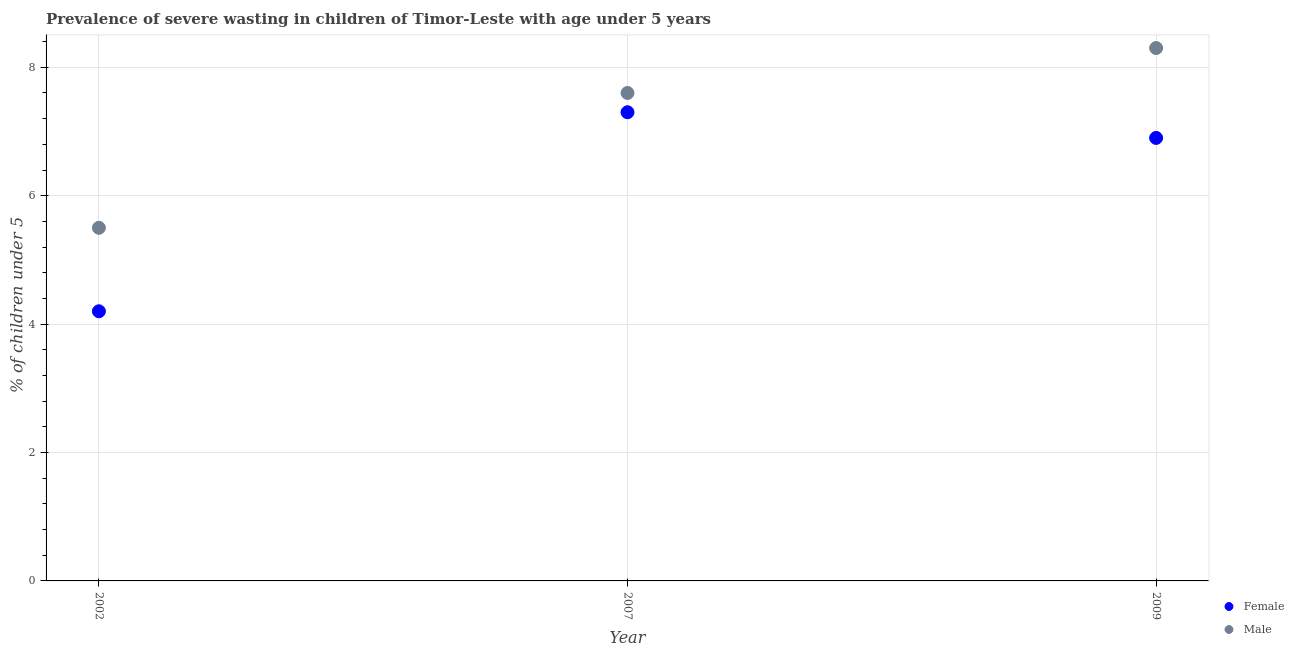How many different coloured dotlines are there?
Ensure brevity in your answer.  2. What is the percentage of undernourished male children in 2007?
Your answer should be very brief. 7.6. Across all years, what is the maximum percentage of undernourished male children?
Offer a terse response. 8.3. In which year was the percentage of undernourished male children maximum?
Offer a very short reply. 2009. In which year was the percentage of undernourished male children minimum?
Your response must be concise. 2002. What is the total percentage of undernourished male children in the graph?
Keep it short and to the point. 21.4. What is the difference between the percentage of undernourished female children in 2007 and that in 2009?
Provide a succinct answer. 0.4. What is the difference between the percentage of undernourished male children in 2002 and the percentage of undernourished female children in 2009?
Make the answer very short. -1.4. What is the average percentage of undernourished male children per year?
Keep it short and to the point. 7.13. In the year 2007, what is the difference between the percentage of undernourished male children and percentage of undernourished female children?
Provide a short and direct response. 0.3. In how many years, is the percentage of undernourished male children greater than 6 %?
Provide a short and direct response. 2. What is the ratio of the percentage of undernourished female children in 2002 to that in 2007?
Keep it short and to the point. 0.58. Is the percentage of undernourished male children in 2002 less than that in 2007?
Give a very brief answer. Yes. Is the difference between the percentage of undernourished male children in 2002 and 2007 greater than the difference between the percentage of undernourished female children in 2002 and 2007?
Provide a succinct answer. Yes. What is the difference between the highest and the second highest percentage of undernourished female children?
Offer a very short reply. 0.4. What is the difference between the highest and the lowest percentage of undernourished male children?
Keep it short and to the point. 2.8. Is the sum of the percentage of undernourished male children in 2002 and 2009 greater than the maximum percentage of undernourished female children across all years?
Offer a terse response. Yes. Does the percentage of undernourished female children monotonically increase over the years?
Your answer should be compact. No. Is the percentage of undernourished female children strictly greater than the percentage of undernourished male children over the years?
Your answer should be compact. No. How many dotlines are there?
Your answer should be very brief. 2. What is the difference between two consecutive major ticks on the Y-axis?
Your answer should be compact. 2. Are the values on the major ticks of Y-axis written in scientific E-notation?
Keep it short and to the point. No. Does the graph contain any zero values?
Provide a succinct answer. No. What is the title of the graph?
Provide a succinct answer. Prevalence of severe wasting in children of Timor-Leste with age under 5 years. What is the label or title of the Y-axis?
Make the answer very short.  % of children under 5. What is the  % of children under 5 of Female in 2002?
Give a very brief answer. 4.2. What is the  % of children under 5 in Male in 2002?
Provide a short and direct response. 5.5. What is the  % of children under 5 of Female in 2007?
Provide a short and direct response. 7.3. What is the  % of children under 5 in Male in 2007?
Give a very brief answer. 7.6. What is the  % of children under 5 of Female in 2009?
Provide a short and direct response. 6.9. What is the  % of children under 5 in Male in 2009?
Provide a succinct answer. 8.3. Across all years, what is the maximum  % of children under 5 in Female?
Give a very brief answer. 7.3. Across all years, what is the maximum  % of children under 5 of Male?
Your answer should be very brief. 8.3. Across all years, what is the minimum  % of children under 5 in Female?
Provide a succinct answer. 4.2. Across all years, what is the minimum  % of children under 5 of Male?
Your answer should be compact. 5.5. What is the total  % of children under 5 in Female in the graph?
Make the answer very short. 18.4. What is the total  % of children under 5 in Male in the graph?
Your response must be concise. 21.4. What is the difference between the  % of children under 5 in Female in 2002 and that in 2009?
Give a very brief answer. -2.7. What is the difference between the  % of children under 5 of Male in 2002 and that in 2009?
Offer a terse response. -2.8. What is the difference between the  % of children under 5 of Female in 2007 and that in 2009?
Ensure brevity in your answer.  0.4. What is the difference between the  % of children under 5 in Male in 2007 and that in 2009?
Your answer should be very brief. -0.7. What is the difference between the  % of children under 5 of Female in 2002 and the  % of children under 5 of Male in 2007?
Provide a short and direct response. -3.4. What is the difference between the  % of children under 5 in Female in 2002 and the  % of children under 5 in Male in 2009?
Offer a very short reply. -4.1. What is the average  % of children under 5 in Female per year?
Your answer should be compact. 6.13. What is the average  % of children under 5 in Male per year?
Your answer should be compact. 7.13. In the year 2002, what is the difference between the  % of children under 5 in Female and  % of children under 5 in Male?
Provide a short and direct response. -1.3. What is the ratio of the  % of children under 5 of Female in 2002 to that in 2007?
Offer a very short reply. 0.58. What is the ratio of the  % of children under 5 in Male in 2002 to that in 2007?
Make the answer very short. 0.72. What is the ratio of the  % of children under 5 of Female in 2002 to that in 2009?
Give a very brief answer. 0.61. What is the ratio of the  % of children under 5 of Male in 2002 to that in 2009?
Your answer should be compact. 0.66. What is the ratio of the  % of children under 5 in Female in 2007 to that in 2009?
Your response must be concise. 1.06. What is the ratio of the  % of children under 5 of Male in 2007 to that in 2009?
Ensure brevity in your answer.  0.92. What is the difference between the highest and the second highest  % of children under 5 in Female?
Offer a very short reply. 0.4. What is the difference between the highest and the lowest  % of children under 5 of Female?
Your response must be concise. 3.1. What is the difference between the highest and the lowest  % of children under 5 of Male?
Your response must be concise. 2.8. 